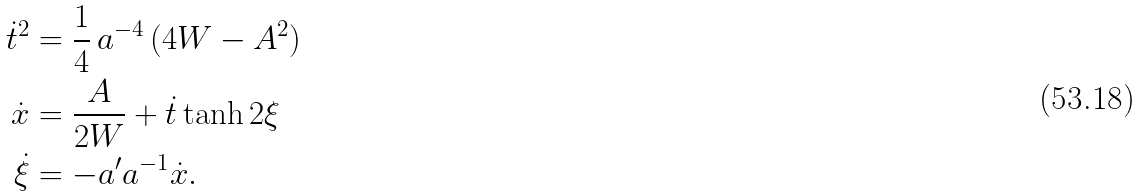Convert formula to latex. <formula><loc_0><loc_0><loc_500><loc_500>\dot { t } ^ { 2 } & = \frac { 1 } { 4 } \, a ^ { - 4 } \, ( 4 W - A ^ { 2 } ) \\ \dot { x } & = \frac { A } { 2 W } + \dot { t } \tanh 2 \xi \\ \dot { \xi } & = - a ^ { \prime } a ^ { - 1 } \dot { x } .</formula> 